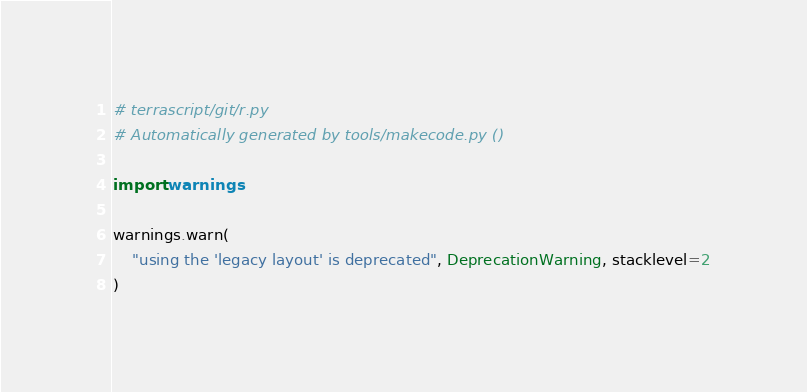Convert code to text. <code><loc_0><loc_0><loc_500><loc_500><_Python_># terrascript/git/r.py
# Automatically generated by tools/makecode.py ()

import warnings

warnings.warn(
    "using the 'legacy layout' is deprecated", DeprecationWarning, stacklevel=2
)
</code> 